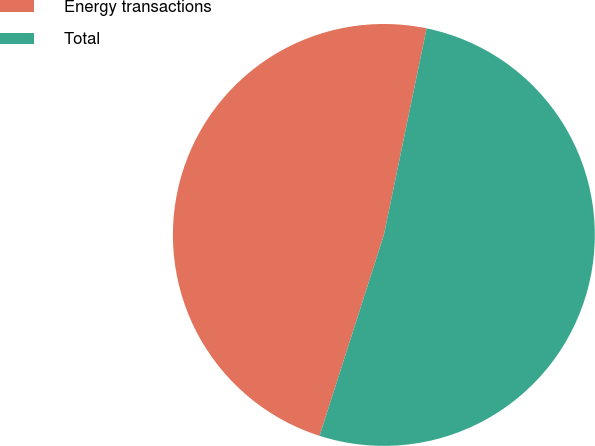<chart> <loc_0><loc_0><loc_500><loc_500><pie_chart><fcel>Energy transactions<fcel>Total<nl><fcel>48.32%<fcel>51.68%<nl></chart> 